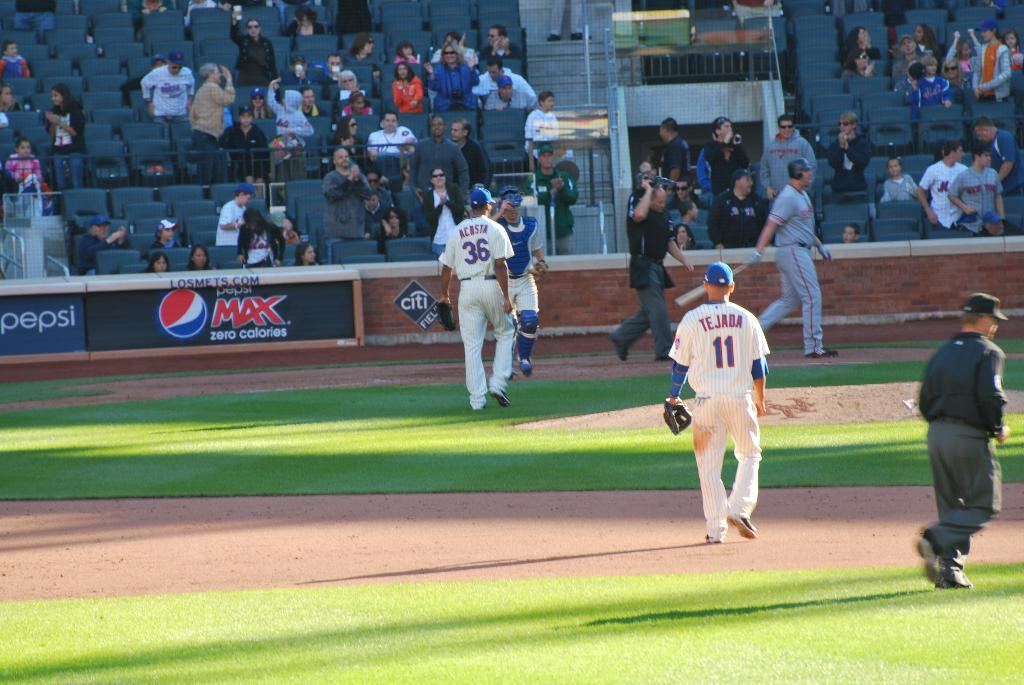Provide a one-sentence caption for the provided image. Acosta and the catcher are walking towards each other. 